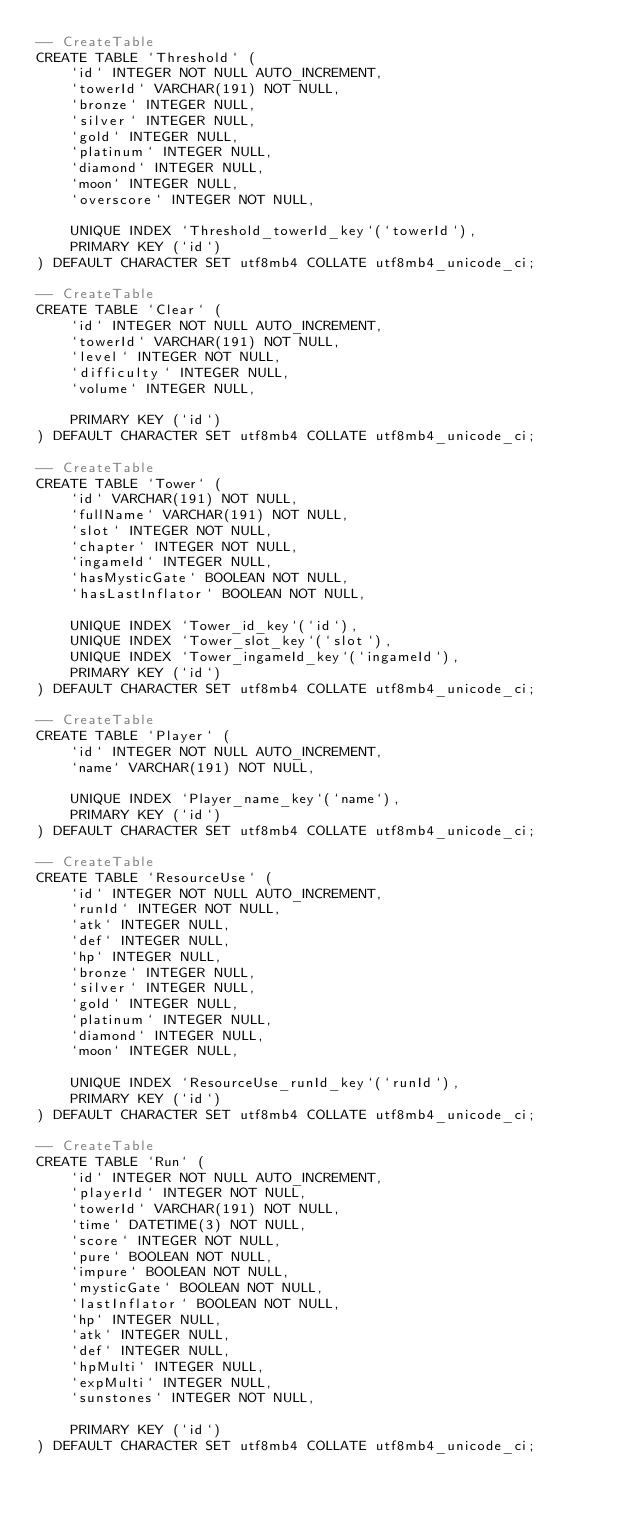Convert code to text. <code><loc_0><loc_0><loc_500><loc_500><_SQL_>-- CreateTable
CREATE TABLE `Threshold` (
    `id` INTEGER NOT NULL AUTO_INCREMENT,
    `towerId` VARCHAR(191) NOT NULL,
    `bronze` INTEGER NULL,
    `silver` INTEGER NULL,
    `gold` INTEGER NULL,
    `platinum` INTEGER NULL,
    `diamond` INTEGER NULL,
    `moon` INTEGER NULL,
    `overscore` INTEGER NOT NULL,

    UNIQUE INDEX `Threshold_towerId_key`(`towerId`),
    PRIMARY KEY (`id`)
) DEFAULT CHARACTER SET utf8mb4 COLLATE utf8mb4_unicode_ci;

-- CreateTable
CREATE TABLE `Clear` (
    `id` INTEGER NOT NULL AUTO_INCREMENT,
    `towerId` VARCHAR(191) NOT NULL,
    `level` INTEGER NOT NULL,
    `difficulty` INTEGER NULL,
    `volume` INTEGER NULL,

    PRIMARY KEY (`id`)
) DEFAULT CHARACTER SET utf8mb4 COLLATE utf8mb4_unicode_ci;

-- CreateTable
CREATE TABLE `Tower` (
    `id` VARCHAR(191) NOT NULL,
    `fullName` VARCHAR(191) NOT NULL,
    `slot` INTEGER NOT NULL,
    `chapter` INTEGER NOT NULL,
    `ingameId` INTEGER NULL,
    `hasMysticGate` BOOLEAN NOT NULL,
    `hasLastInflator` BOOLEAN NOT NULL,

    UNIQUE INDEX `Tower_id_key`(`id`),
    UNIQUE INDEX `Tower_slot_key`(`slot`),
    UNIQUE INDEX `Tower_ingameId_key`(`ingameId`),
    PRIMARY KEY (`id`)
) DEFAULT CHARACTER SET utf8mb4 COLLATE utf8mb4_unicode_ci;

-- CreateTable
CREATE TABLE `Player` (
    `id` INTEGER NOT NULL AUTO_INCREMENT,
    `name` VARCHAR(191) NOT NULL,

    UNIQUE INDEX `Player_name_key`(`name`),
    PRIMARY KEY (`id`)
) DEFAULT CHARACTER SET utf8mb4 COLLATE utf8mb4_unicode_ci;

-- CreateTable
CREATE TABLE `ResourceUse` (
    `id` INTEGER NOT NULL AUTO_INCREMENT,
    `runId` INTEGER NOT NULL,
    `atk` INTEGER NULL,
    `def` INTEGER NULL,
    `hp` INTEGER NULL,
    `bronze` INTEGER NULL,
    `silver` INTEGER NULL,
    `gold` INTEGER NULL,
    `platinum` INTEGER NULL,
    `diamond` INTEGER NULL,
    `moon` INTEGER NULL,

    UNIQUE INDEX `ResourceUse_runId_key`(`runId`),
    PRIMARY KEY (`id`)
) DEFAULT CHARACTER SET utf8mb4 COLLATE utf8mb4_unicode_ci;

-- CreateTable
CREATE TABLE `Run` (
    `id` INTEGER NOT NULL AUTO_INCREMENT,
    `playerId` INTEGER NOT NULL,
    `towerId` VARCHAR(191) NOT NULL,
    `time` DATETIME(3) NOT NULL,
    `score` INTEGER NOT NULL,
    `pure` BOOLEAN NOT NULL,
    `impure` BOOLEAN NOT NULL,
    `mysticGate` BOOLEAN NOT NULL,
    `lastInflator` BOOLEAN NOT NULL,
    `hp` INTEGER NULL,
    `atk` INTEGER NULL,
    `def` INTEGER NULL,
    `hpMulti` INTEGER NULL,
    `expMulti` INTEGER NULL,
    `sunstones` INTEGER NOT NULL,

    PRIMARY KEY (`id`)
) DEFAULT CHARACTER SET utf8mb4 COLLATE utf8mb4_unicode_ci;
</code> 